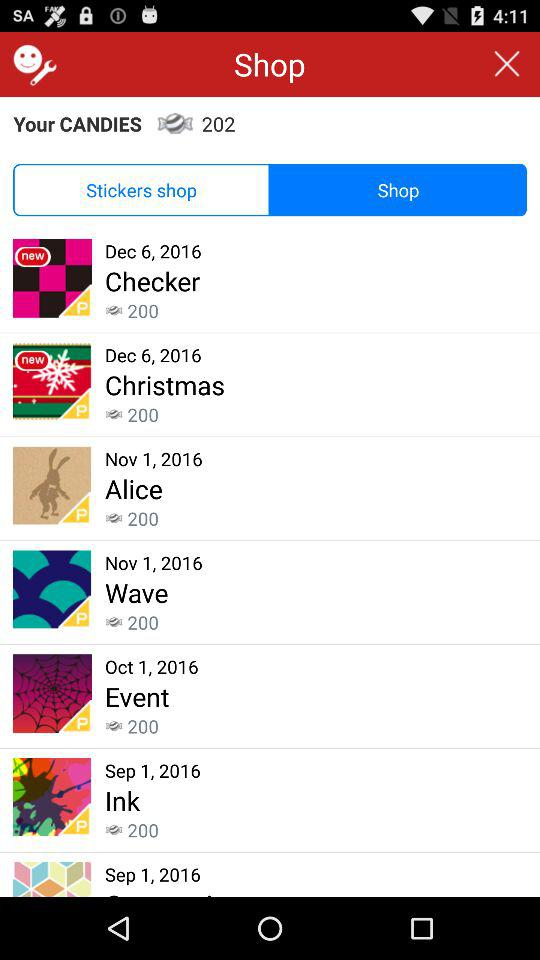What is the date for "Wave"? The date for "Wave" is November 1, 2016. 